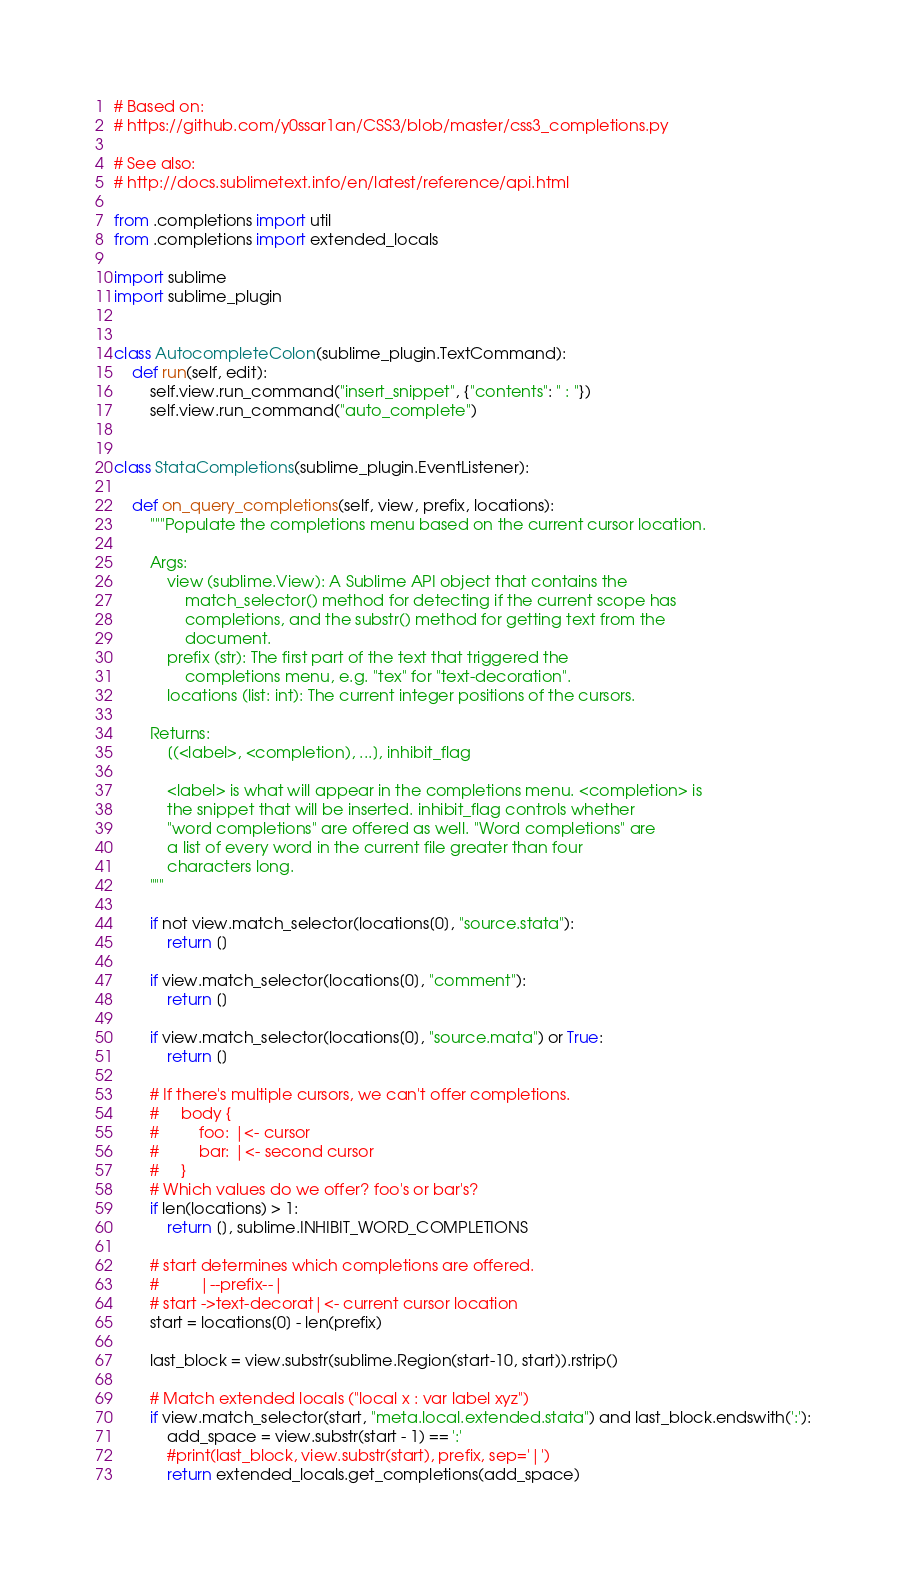<code> <loc_0><loc_0><loc_500><loc_500><_Python_># Based on:
# https://github.com/y0ssar1an/CSS3/blob/master/css3_completions.py

# See also:
# http://docs.sublimetext.info/en/latest/reference/api.html

from .completions import util
from .completions import extended_locals

import sublime
import sublime_plugin


class AutocompleteColon(sublime_plugin.TextCommand):
    def run(self, edit):
        self.view.run_command("insert_snippet", {"contents": " : "})
        self.view.run_command("auto_complete")


class StataCompletions(sublime_plugin.EventListener):

    def on_query_completions(self, view, prefix, locations):
        """Populate the completions menu based on the current cursor location.

        Args:
            view (sublime.View): A Sublime API object that contains the
                match_selector() method for detecting if the current scope has
                completions, and the substr() method for getting text from the
                document.
            prefix (str): The first part of the text that triggered the
                completions menu, e.g. "tex" for "text-decoration".
            locations (list: int): The current integer positions of the cursors.

        Returns:
            [(<label>, <completion), ...], inhibit_flag

            <label> is what will appear in the completions menu. <completion> is
            the snippet that will be inserted. inhibit_flag controls whether
            "word completions" are offered as well. "Word completions" are
            a list of every word in the current file greater than four
            characters long.
        """

        if not view.match_selector(locations[0], "source.stata"):
            return []

        if view.match_selector(locations[0], "comment"):
            return []

        if view.match_selector(locations[0], "source.mata") or True:
            return []

        # If there's multiple cursors, we can't offer completions.
        #     body {
        #         foo: |<- cursor
        #         bar: |<- second cursor
        #     }
        # Which values do we offer? foo's or bar's?
        if len(locations) > 1:
            return [], sublime.INHIBIT_WORD_COMPLETIONS

        # start determines which completions are offered.
        #         |--prefix--|
        # start ->text-decorat|<- current cursor location
        start = locations[0] - len(prefix)

        last_block = view.substr(sublime.Region(start-10, start)).rstrip()

        # Match extended locals ("local x : var label xyz")
        if view.match_selector(start, "meta.local.extended.stata") and last_block.endswith(':'):
            add_space = view.substr(start - 1) == ':'
            #print(last_block, view.substr(start), prefix, sep='|')
            return extended_locals.get_completions(add_space)
</code> 